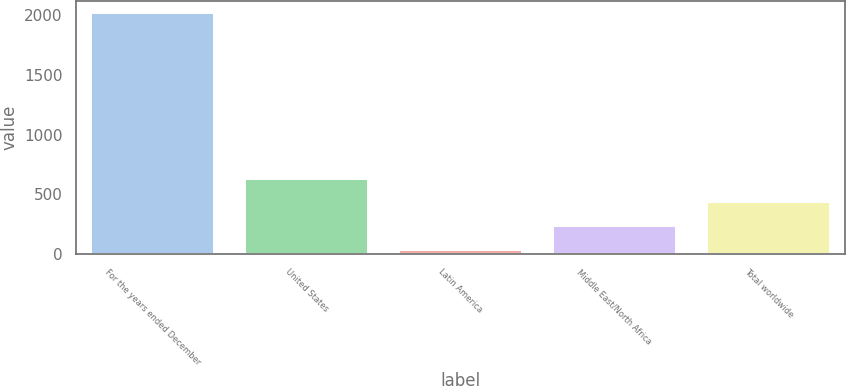Convert chart to OTSL. <chart><loc_0><loc_0><loc_500><loc_500><bar_chart><fcel>For the years ended December<fcel>United States<fcel>Latin America<fcel>Middle East/North Africa<fcel>Total worldwide<nl><fcel>2016<fcel>631.03<fcel>37.48<fcel>235.33<fcel>433.18<nl></chart> 